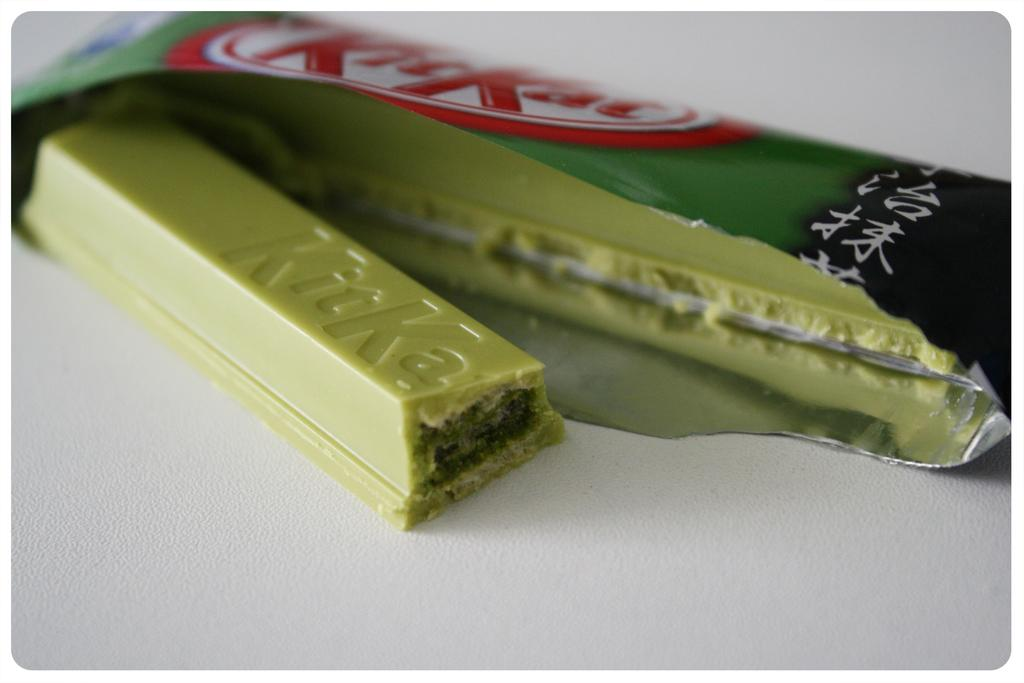What type of chocolate is in the image? There is a kit kat chocolate in the image. Where is the kit kat chocolate located? The kit kat chocolate is on a table. Is there a veil covering the kit kat chocolate in the image? No, there is no veil present in the image, and the kit kat chocolate is not covered. 